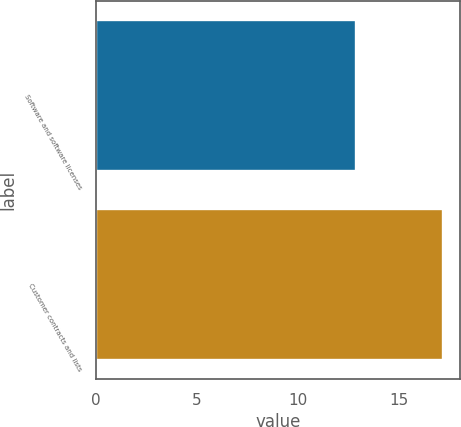Convert chart. <chart><loc_0><loc_0><loc_500><loc_500><bar_chart><fcel>Software and software licenses<fcel>Customer contracts and lists<nl><fcel>12.9<fcel>17.2<nl></chart> 